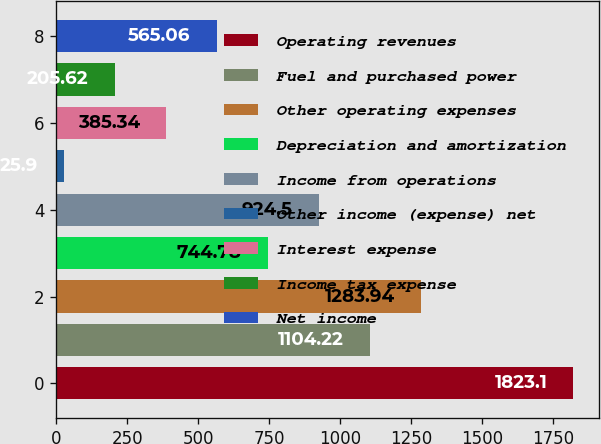<chart> <loc_0><loc_0><loc_500><loc_500><bar_chart><fcel>Operating revenues<fcel>Fuel and purchased power<fcel>Other operating expenses<fcel>Depreciation and amortization<fcel>Income from operations<fcel>Other income (expense) net<fcel>Interest expense<fcel>Income tax expense<fcel>Net income<nl><fcel>1823.1<fcel>1104.22<fcel>1283.94<fcel>744.78<fcel>924.5<fcel>25.9<fcel>385.34<fcel>205.62<fcel>565.06<nl></chart> 